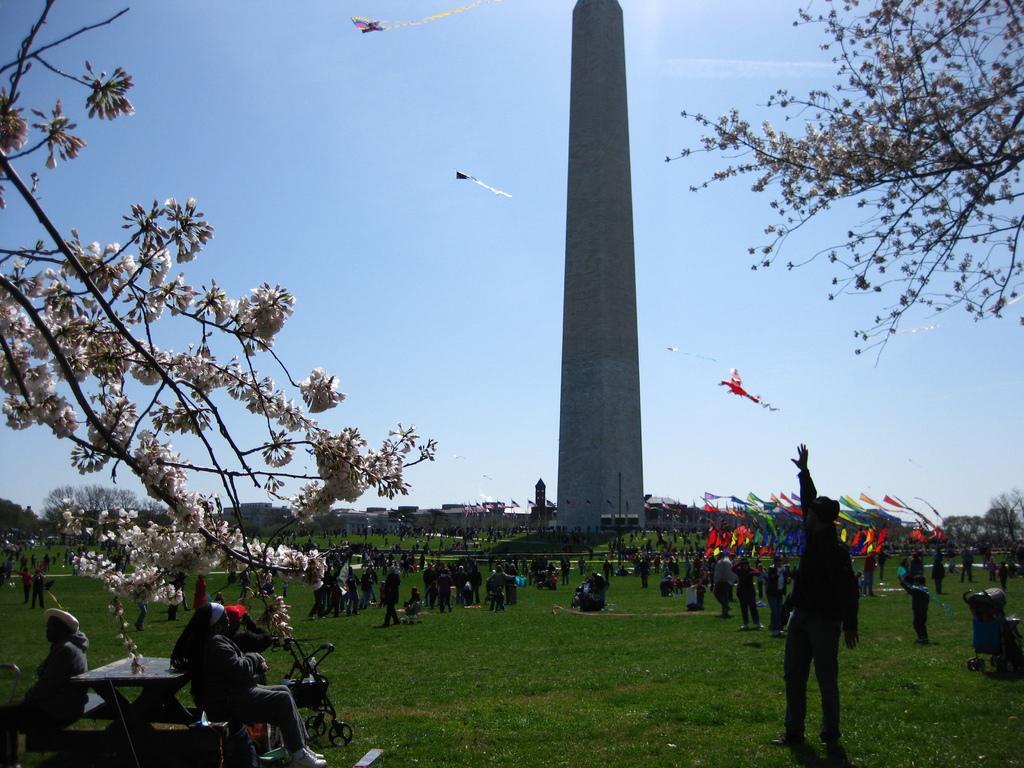How would you summarize this image in a sentence or two? In this image we can see a group of people on the ground. We can also see a trolley, a table, some benches, grass, a trash bin and some poles. On the backside we can see a tower, trees, the flags, some buildings and the kites in the sky. 